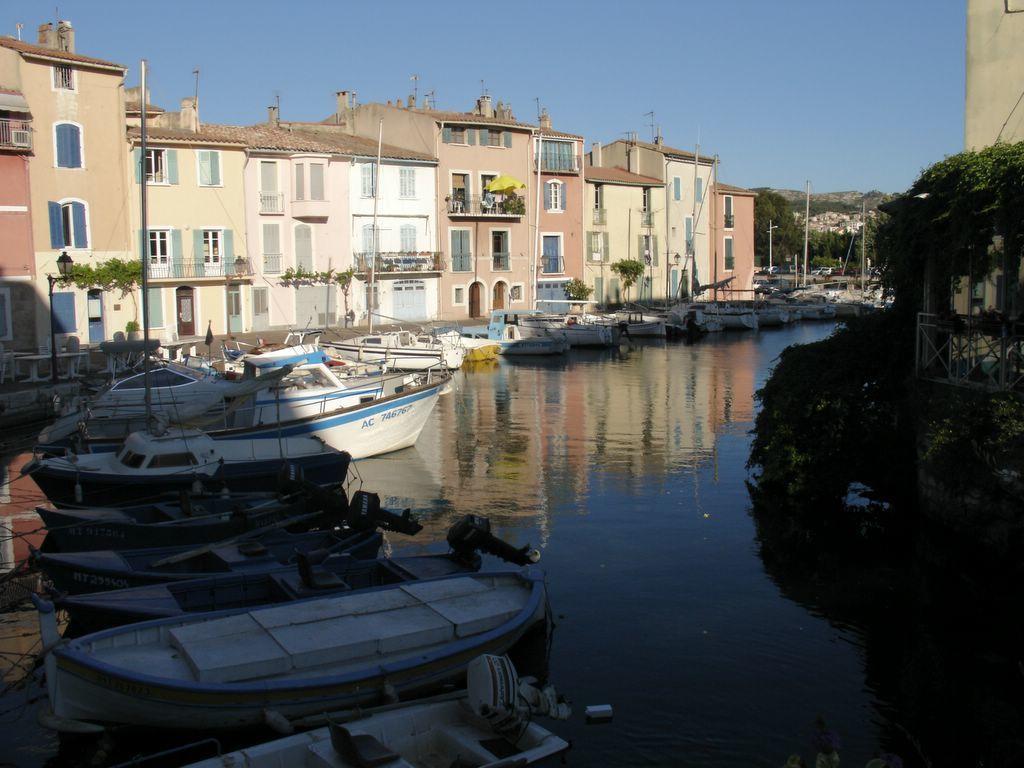In one or two sentences, can you explain what this image depicts? In this picture I can see a number of boats on the water. I can see trees on the right side. I can see the buildings on the left side. I can see clouds in the sky. 